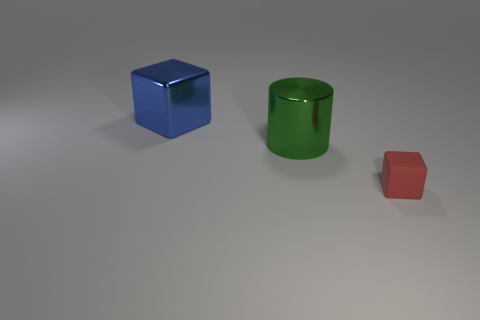There is a shiny object that is to the left of the metallic thing to the right of the large blue thing; is there a rubber block left of it?
Provide a succinct answer. No. There is a tiny object that is the same shape as the big blue metal object; what material is it?
Your response must be concise. Rubber. What is the color of the object that is to the left of the green metal cylinder?
Offer a terse response. Blue. How big is the blue metal cube?
Give a very brief answer. Large. Is the size of the green thing the same as the cube that is behind the tiny block?
Offer a very short reply. Yes. What color is the block that is behind the block on the right side of the large metal thing in front of the big cube?
Keep it short and to the point. Blue. Is the large thing in front of the large block made of the same material as the large blue thing?
Provide a succinct answer. Yes. What number of other things are the same material as the green cylinder?
Make the answer very short. 1. There is a cylinder that is the same size as the blue shiny thing; what is it made of?
Provide a succinct answer. Metal. There is a big object that is right of the blue metallic object; is its shape the same as the large object that is behind the big cylinder?
Make the answer very short. No. 